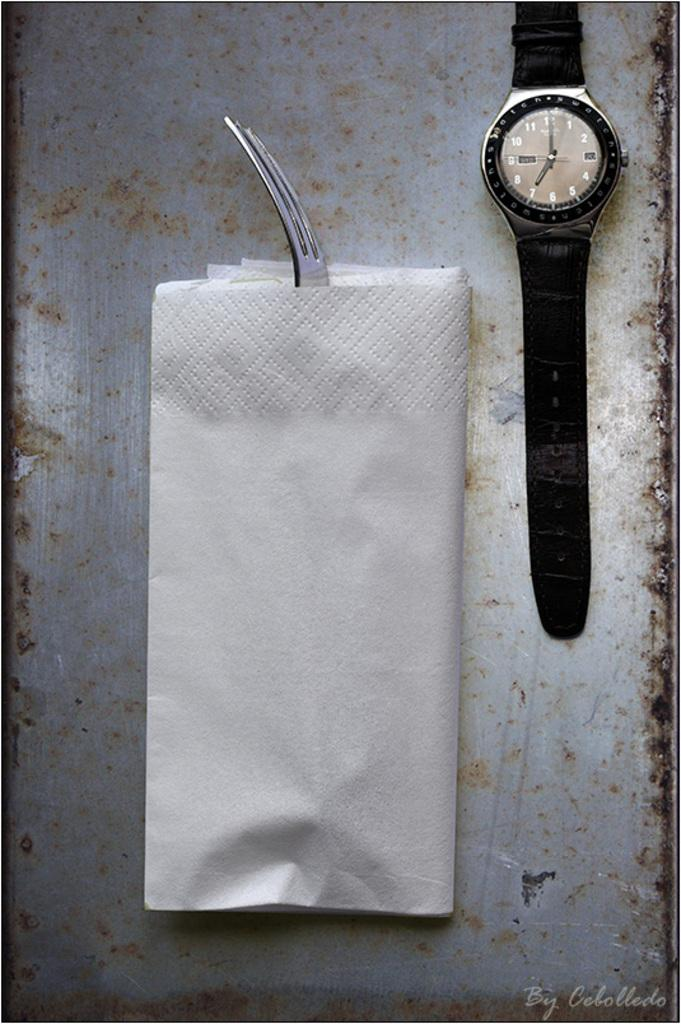Provide a one-sentence caption for the provided image. a watch with 1 thru 12 on the front. 